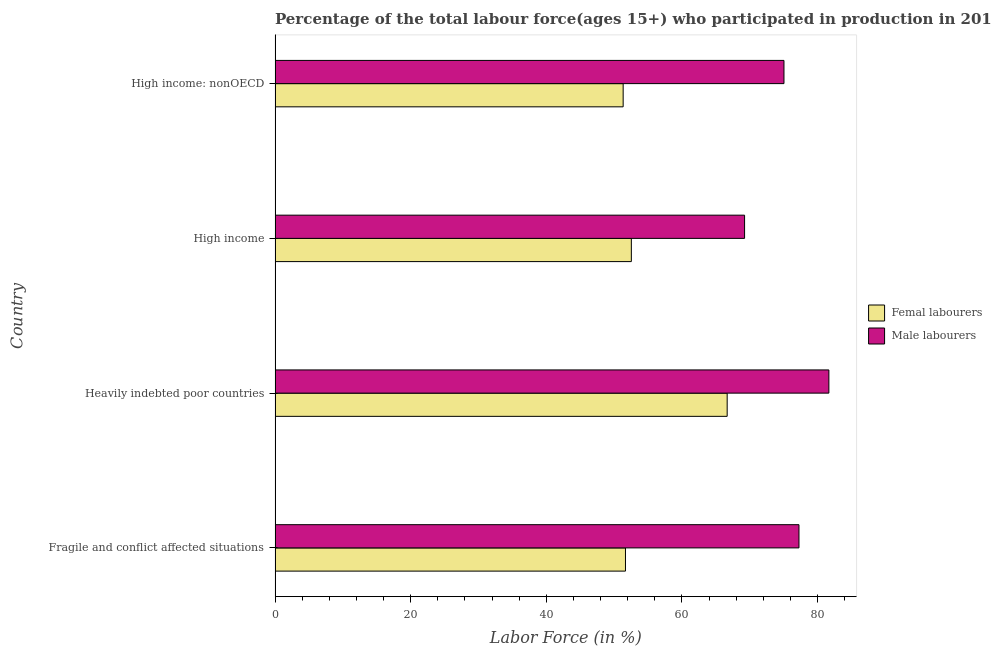How many different coloured bars are there?
Ensure brevity in your answer.  2. How many groups of bars are there?
Offer a terse response. 4. Are the number of bars per tick equal to the number of legend labels?
Ensure brevity in your answer.  Yes. How many bars are there on the 1st tick from the top?
Offer a terse response. 2. What is the label of the 3rd group of bars from the top?
Offer a very short reply. Heavily indebted poor countries. In how many cases, is the number of bars for a given country not equal to the number of legend labels?
Give a very brief answer. 0. What is the percentage of female labor force in Heavily indebted poor countries?
Your answer should be very brief. 66.67. Across all countries, what is the maximum percentage of female labor force?
Offer a very short reply. 66.67. Across all countries, what is the minimum percentage of male labour force?
Give a very brief answer. 69.23. In which country was the percentage of female labor force maximum?
Make the answer very short. Heavily indebted poor countries. In which country was the percentage of female labor force minimum?
Provide a succinct answer. High income: nonOECD. What is the total percentage of female labor force in the graph?
Offer a terse response. 222.2. What is the difference between the percentage of male labour force in Heavily indebted poor countries and that in High income?
Your answer should be very brief. 12.43. What is the difference between the percentage of female labor force in High income: nonOECD and the percentage of male labour force in Fragile and conflict affected situations?
Your response must be concise. -25.93. What is the average percentage of female labor force per country?
Offer a very short reply. 55.55. What is the difference between the percentage of male labour force and percentage of female labor force in Heavily indebted poor countries?
Give a very brief answer. 15. What is the difference between the highest and the second highest percentage of female labor force?
Make the answer very short. 14.13. What is the difference between the highest and the lowest percentage of male labour force?
Offer a terse response. 12.43. In how many countries, is the percentage of female labor force greater than the average percentage of female labor force taken over all countries?
Your answer should be compact. 1. Is the sum of the percentage of female labor force in Fragile and conflict affected situations and High income greater than the maximum percentage of male labour force across all countries?
Provide a succinct answer. Yes. What does the 2nd bar from the top in High income represents?
Give a very brief answer. Femal labourers. What does the 1st bar from the bottom in Heavily indebted poor countries represents?
Provide a short and direct response. Femal labourers. Does the graph contain grids?
Offer a very short reply. No. How many legend labels are there?
Provide a succinct answer. 2. How are the legend labels stacked?
Provide a short and direct response. Vertical. What is the title of the graph?
Provide a short and direct response. Percentage of the total labour force(ages 15+) who participated in production in 2014. What is the Labor Force (in %) in Femal labourers in Fragile and conflict affected situations?
Ensure brevity in your answer.  51.67. What is the Labor Force (in %) of Male labourers in Fragile and conflict affected situations?
Ensure brevity in your answer.  77.25. What is the Labor Force (in %) of Femal labourers in Heavily indebted poor countries?
Make the answer very short. 66.67. What is the Labor Force (in %) of Male labourers in Heavily indebted poor countries?
Provide a succinct answer. 81.67. What is the Labor Force (in %) of Femal labourers in High income?
Keep it short and to the point. 52.54. What is the Labor Force (in %) in Male labourers in High income?
Make the answer very short. 69.23. What is the Labor Force (in %) of Femal labourers in High income: nonOECD?
Make the answer very short. 51.33. What is the Labor Force (in %) in Male labourers in High income: nonOECD?
Your answer should be very brief. 75.04. Across all countries, what is the maximum Labor Force (in %) of Femal labourers?
Keep it short and to the point. 66.67. Across all countries, what is the maximum Labor Force (in %) in Male labourers?
Your response must be concise. 81.67. Across all countries, what is the minimum Labor Force (in %) in Femal labourers?
Your answer should be compact. 51.33. Across all countries, what is the minimum Labor Force (in %) of Male labourers?
Make the answer very short. 69.23. What is the total Labor Force (in %) in Femal labourers in the graph?
Your answer should be compact. 222.2. What is the total Labor Force (in %) in Male labourers in the graph?
Give a very brief answer. 303.2. What is the difference between the Labor Force (in %) of Femal labourers in Fragile and conflict affected situations and that in Heavily indebted poor countries?
Your response must be concise. -15. What is the difference between the Labor Force (in %) in Male labourers in Fragile and conflict affected situations and that in Heavily indebted poor countries?
Offer a terse response. -4.41. What is the difference between the Labor Force (in %) of Femal labourers in Fragile and conflict affected situations and that in High income?
Your answer should be very brief. -0.87. What is the difference between the Labor Force (in %) in Male labourers in Fragile and conflict affected situations and that in High income?
Ensure brevity in your answer.  8.02. What is the difference between the Labor Force (in %) of Femal labourers in Fragile and conflict affected situations and that in High income: nonOECD?
Keep it short and to the point. 0.34. What is the difference between the Labor Force (in %) of Male labourers in Fragile and conflict affected situations and that in High income: nonOECD?
Your answer should be compact. 2.21. What is the difference between the Labor Force (in %) of Femal labourers in Heavily indebted poor countries and that in High income?
Make the answer very short. 14.13. What is the difference between the Labor Force (in %) in Male labourers in Heavily indebted poor countries and that in High income?
Your response must be concise. 12.43. What is the difference between the Labor Force (in %) in Femal labourers in Heavily indebted poor countries and that in High income: nonOECD?
Offer a very short reply. 15.34. What is the difference between the Labor Force (in %) of Male labourers in Heavily indebted poor countries and that in High income: nonOECD?
Keep it short and to the point. 6.62. What is the difference between the Labor Force (in %) in Femal labourers in High income and that in High income: nonOECD?
Ensure brevity in your answer.  1.21. What is the difference between the Labor Force (in %) in Male labourers in High income and that in High income: nonOECD?
Keep it short and to the point. -5.81. What is the difference between the Labor Force (in %) in Femal labourers in Fragile and conflict affected situations and the Labor Force (in %) in Male labourers in Heavily indebted poor countries?
Make the answer very short. -30. What is the difference between the Labor Force (in %) in Femal labourers in Fragile and conflict affected situations and the Labor Force (in %) in Male labourers in High income?
Provide a succinct answer. -17.56. What is the difference between the Labor Force (in %) in Femal labourers in Fragile and conflict affected situations and the Labor Force (in %) in Male labourers in High income: nonOECD?
Your response must be concise. -23.37. What is the difference between the Labor Force (in %) in Femal labourers in Heavily indebted poor countries and the Labor Force (in %) in Male labourers in High income?
Give a very brief answer. -2.57. What is the difference between the Labor Force (in %) of Femal labourers in Heavily indebted poor countries and the Labor Force (in %) of Male labourers in High income: nonOECD?
Your answer should be very brief. -8.38. What is the difference between the Labor Force (in %) of Femal labourers in High income and the Labor Force (in %) of Male labourers in High income: nonOECD?
Offer a terse response. -22.51. What is the average Labor Force (in %) of Femal labourers per country?
Keep it short and to the point. 55.55. What is the average Labor Force (in %) in Male labourers per country?
Your answer should be compact. 75.8. What is the difference between the Labor Force (in %) in Femal labourers and Labor Force (in %) in Male labourers in Fragile and conflict affected situations?
Give a very brief answer. -25.58. What is the difference between the Labor Force (in %) in Femal labourers and Labor Force (in %) in Male labourers in Heavily indebted poor countries?
Offer a terse response. -15. What is the difference between the Labor Force (in %) of Femal labourers and Labor Force (in %) of Male labourers in High income?
Your response must be concise. -16.7. What is the difference between the Labor Force (in %) in Femal labourers and Labor Force (in %) in Male labourers in High income: nonOECD?
Keep it short and to the point. -23.71. What is the ratio of the Labor Force (in %) in Femal labourers in Fragile and conflict affected situations to that in Heavily indebted poor countries?
Offer a terse response. 0.78. What is the ratio of the Labor Force (in %) of Male labourers in Fragile and conflict affected situations to that in Heavily indebted poor countries?
Offer a very short reply. 0.95. What is the ratio of the Labor Force (in %) in Femal labourers in Fragile and conflict affected situations to that in High income?
Offer a very short reply. 0.98. What is the ratio of the Labor Force (in %) of Male labourers in Fragile and conflict affected situations to that in High income?
Your answer should be compact. 1.12. What is the ratio of the Labor Force (in %) of Femal labourers in Fragile and conflict affected situations to that in High income: nonOECD?
Offer a terse response. 1.01. What is the ratio of the Labor Force (in %) in Male labourers in Fragile and conflict affected situations to that in High income: nonOECD?
Offer a terse response. 1.03. What is the ratio of the Labor Force (in %) in Femal labourers in Heavily indebted poor countries to that in High income?
Keep it short and to the point. 1.27. What is the ratio of the Labor Force (in %) in Male labourers in Heavily indebted poor countries to that in High income?
Give a very brief answer. 1.18. What is the ratio of the Labor Force (in %) of Femal labourers in Heavily indebted poor countries to that in High income: nonOECD?
Provide a succinct answer. 1.3. What is the ratio of the Labor Force (in %) of Male labourers in Heavily indebted poor countries to that in High income: nonOECD?
Offer a very short reply. 1.09. What is the ratio of the Labor Force (in %) in Femal labourers in High income to that in High income: nonOECD?
Your answer should be compact. 1.02. What is the ratio of the Labor Force (in %) of Male labourers in High income to that in High income: nonOECD?
Offer a terse response. 0.92. What is the difference between the highest and the second highest Labor Force (in %) of Femal labourers?
Give a very brief answer. 14.13. What is the difference between the highest and the second highest Labor Force (in %) in Male labourers?
Give a very brief answer. 4.41. What is the difference between the highest and the lowest Labor Force (in %) of Femal labourers?
Offer a terse response. 15.34. What is the difference between the highest and the lowest Labor Force (in %) in Male labourers?
Your answer should be very brief. 12.43. 